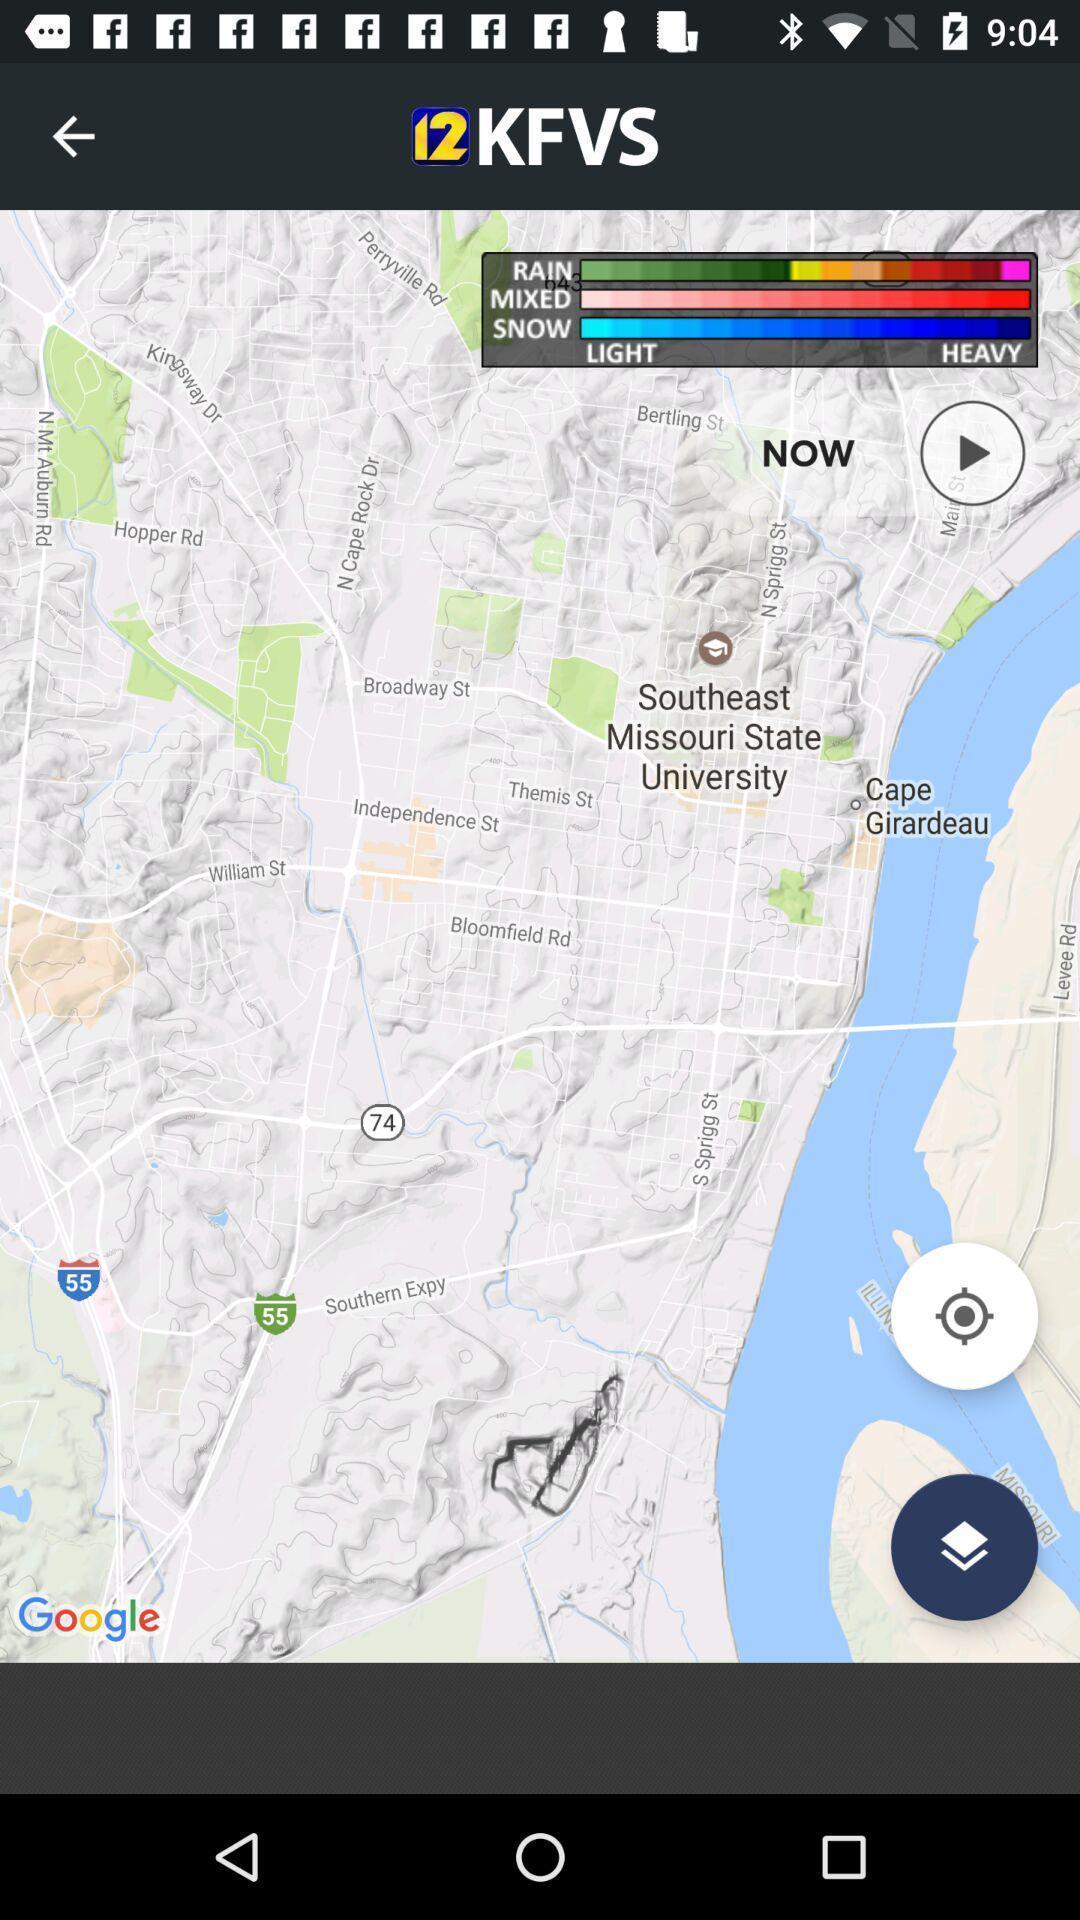Summarize the information in this screenshot. Page showing the locations in maps. 